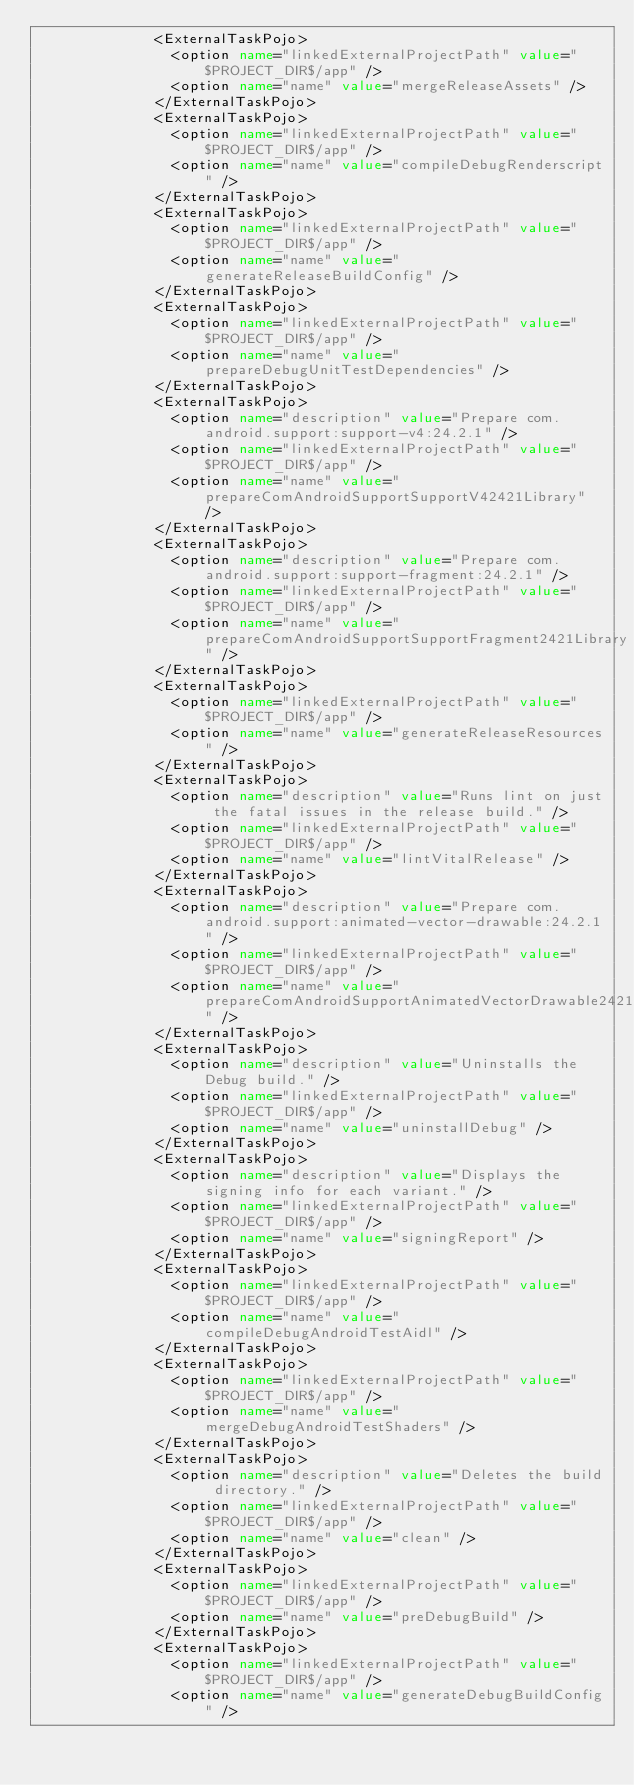<code> <loc_0><loc_0><loc_500><loc_500><_XML_>              <ExternalTaskPojo>
                <option name="linkedExternalProjectPath" value="$PROJECT_DIR$/app" />
                <option name="name" value="mergeReleaseAssets" />
              </ExternalTaskPojo>
              <ExternalTaskPojo>
                <option name="linkedExternalProjectPath" value="$PROJECT_DIR$/app" />
                <option name="name" value="compileDebugRenderscript" />
              </ExternalTaskPojo>
              <ExternalTaskPojo>
                <option name="linkedExternalProjectPath" value="$PROJECT_DIR$/app" />
                <option name="name" value="generateReleaseBuildConfig" />
              </ExternalTaskPojo>
              <ExternalTaskPojo>
                <option name="linkedExternalProjectPath" value="$PROJECT_DIR$/app" />
                <option name="name" value="prepareDebugUnitTestDependencies" />
              </ExternalTaskPojo>
              <ExternalTaskPojo>
                <option name="description" value="Prepare com.android.support:support-v4:24.2.1" />
                <option name="linkedExternalProjectPath" value="$PROJECT_DIR$/app" />
                <option name="name" value="prepareComAndroidSupportSupportV42421Library" />
              </ExternalTaskPojo>
              <ExternalTaskPojo>
                <option name="description" value="Prepare com.android.support:support-fragment:24.2.1" />
                <option name="linkedExternalProjectPath" value="$PROJECT_DIR$/app" />
                <option name="name" value="prepareComAndroidSupportSupportFragment2421Library" />
              </ExternalTaskPojo>
              <ExternalTaskPojo>
                <option name="linkedExternalProjectPath" value="$PROJECT_DIR$/app" />
                <option name="name" value="generateReleaseResources" />
              </ExternalTaskPojo>
              <ExternalTaskPojo>
                <option name="description" value="Runs lint on just the fatal issues in the release build." />
                <option name="linkedExternalProjectPath" value="$PROJECT_DIR$/app" />
                <option name="name" value="lintVitalRelease" />
              </ExternalTaskPojo>
              <ExternalTaskPojo>
                <option name="description" value="Prepare com.android.support:animated-vector-drawable:24.2.1" />
                <option name="linkedExternalProjectPath" value="$PROJECT_DIR$/app" />
                <option name="name" value="prepareComAndroidSupportAnimatedVectorDrawable2421Library" />
              </ExternalTaskPojo>
              <ExternalTaskPojo>
                <option name="description" value="Uninstalls the Debug build." />
                <option name="linkedExternalProjectPath" value="$PROJECT_DIR$/app" />
                <option name="name" value="uninstallDebug" />
              </ExternalTaskPojo>
              <ExternalTaskPojo>
                <option name="description" value="Displays the signing info for each variant." />
                <option name="linkedExternalProjectPath" value="$PROJECT_DIR$/app" />
                <option name="name" value="signingReport" />
              </ExternalTaskPojo>
              <ExternalTaskPojo>
                <option name="linkedExternalProjectPath" value="$PROJECT_DIR$/app" />
                <option name="name" value="compileDebugAndroidTestAidl" />
              </ExternalTaskPojo>
              <ExternalTaskPojo>
                <option name="linkedExternalProjectPath" value="$PROJECT_DIR$/app" />
                <option name="name" value="mergeDebugAndroidTestShaders" />
              </ExternalTaskPojo>
              <ExternalTaskPojo>
                <option name="description" value="Deletes the build directory." />
                <option name="linkedExternalProjectPath" value="$PROJECT_DIR$/app" />
                <option name="name" value="clean" />
              </ExternalTaskPojo>
              <ExternalTaskPojo>
                <option name="linkedExternalProjectPath" value="$PROJECT_DIR$/app" />
                <option name="name" value="preDebugBuild" />
              </ExternalTaskPojo>
              <ExternalTaskPojo>
                <option name="linkedExternalProjectPath" value="$PROJECT_DIR$/app" />
                <option name="name" value="generateDebugBuildConfig" /></code> 